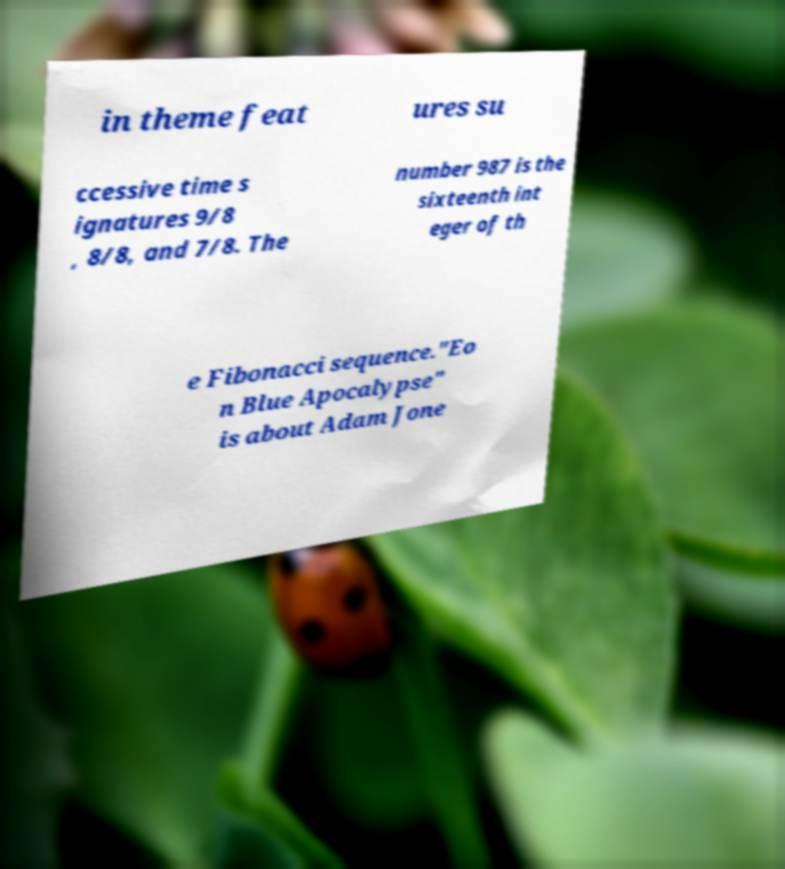What messages or text are displayed in this image? I need them in a readable, typed format. in theme feat ures su ccessive time s ignatures 9/8 , 8/8, and 7/8. The number 987 is the sixteenth int eger of th e Fibonacci sequence."Eo n Blue Apocalypse" is about Adam Jone 